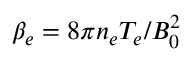Convert formula to latex. <formula><loc_0><loc_0><loc_500><loc_500>\beta _ { e } = 8 \pi n _ { e } T _ { e } / B _ { 0 } ^ { 2 }</formula> 